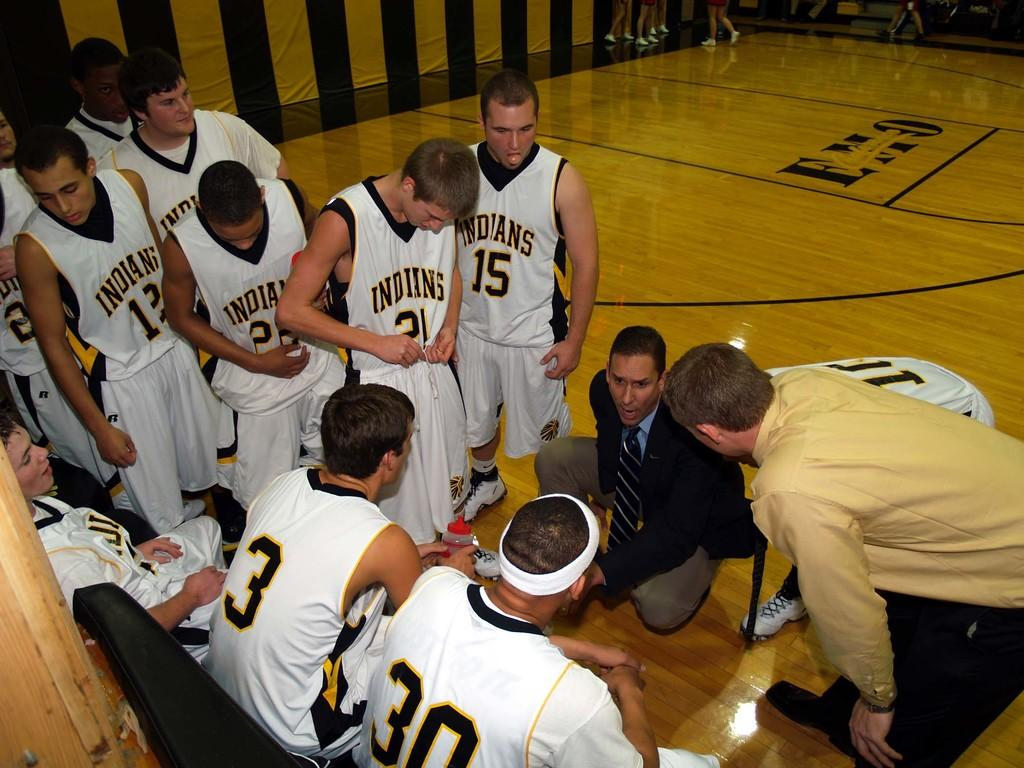<image>
Render a clear and concise summary of the photo. some sports players, one of whom is wearing a shirt with 15 on it. 